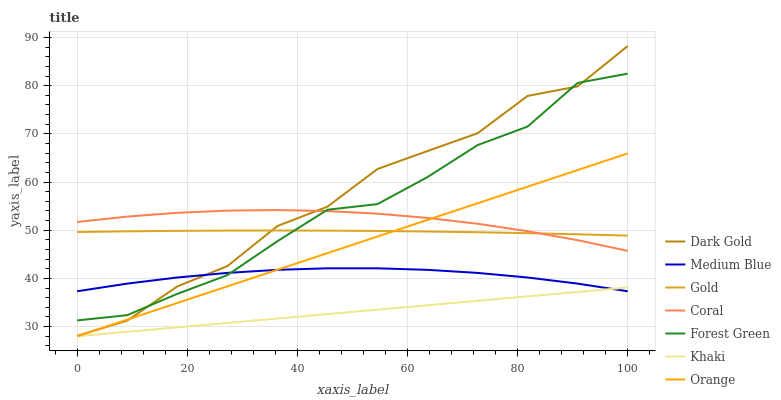Does Khaki have the minimum area under the curve?
Answer yes or no. Yes. Does Dark Gold have the maximum area under the curve?
Answer yes or no. Yes. Does Gold have the minimum area under the curve?
Answer yes or no. No. Does Gold have the maximum area under the curve?
Answer yes or no. No. Is Khaki the smoothest?
Answer yes or no. Yes. Is Dark Gold the roughest?
Answer yes or no. Yes. Is Gold the smoothest?
Answer yes or no. No. Is Gold the roughest?
Answer yes or no. No. Does Khaki have the lowest value?
Answer yes or no. Yes. Does Dark Gold have the lowest value?
Answer yes or no. No. Does Dark Gold have the highest value?
Answer yes or no. Yes. Does Gold have the highest value?
Answer yes or no. No. Is Khaki less than Forest Green?
Answer yes or no. Yes. Is Forest Green greater than Orange?
Answer yes or no. Yes. Does Khaki intersect Orange?
Answer yes or no. Yes. Is Khaki less than Orange?
Answer yes or no. No. Is Khaki greater than Orange?
Answer yes or no. No. Does Khaki intersect Forest Green?
Answer yes or no. No. 